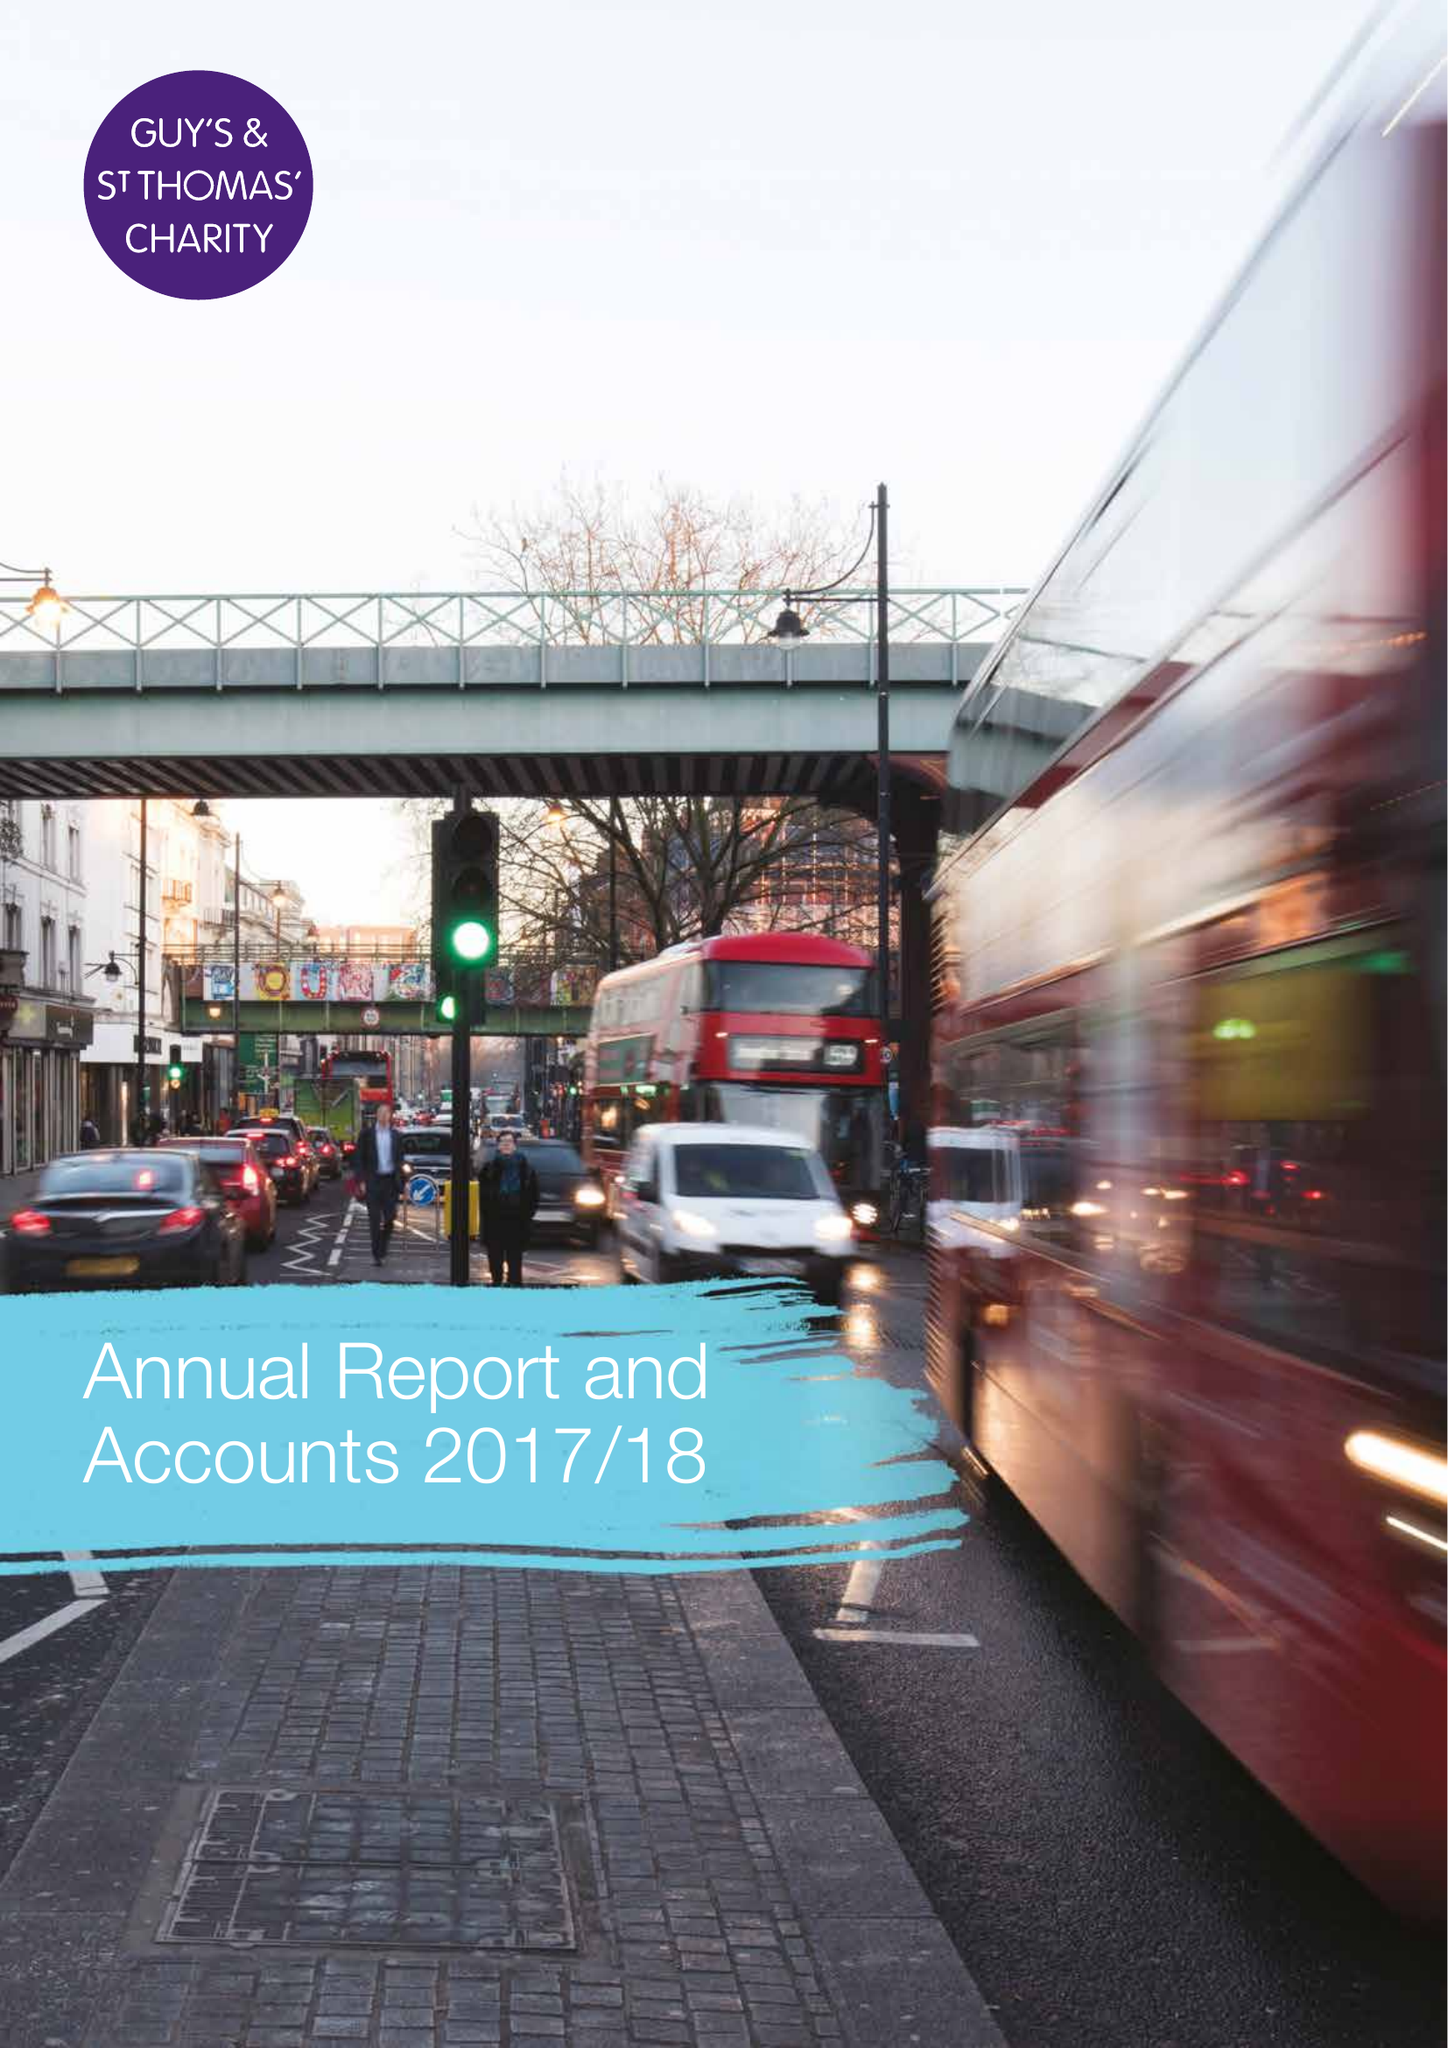What is the value for the charity_number?
Answer the question using a single word or phrase. 1160316 